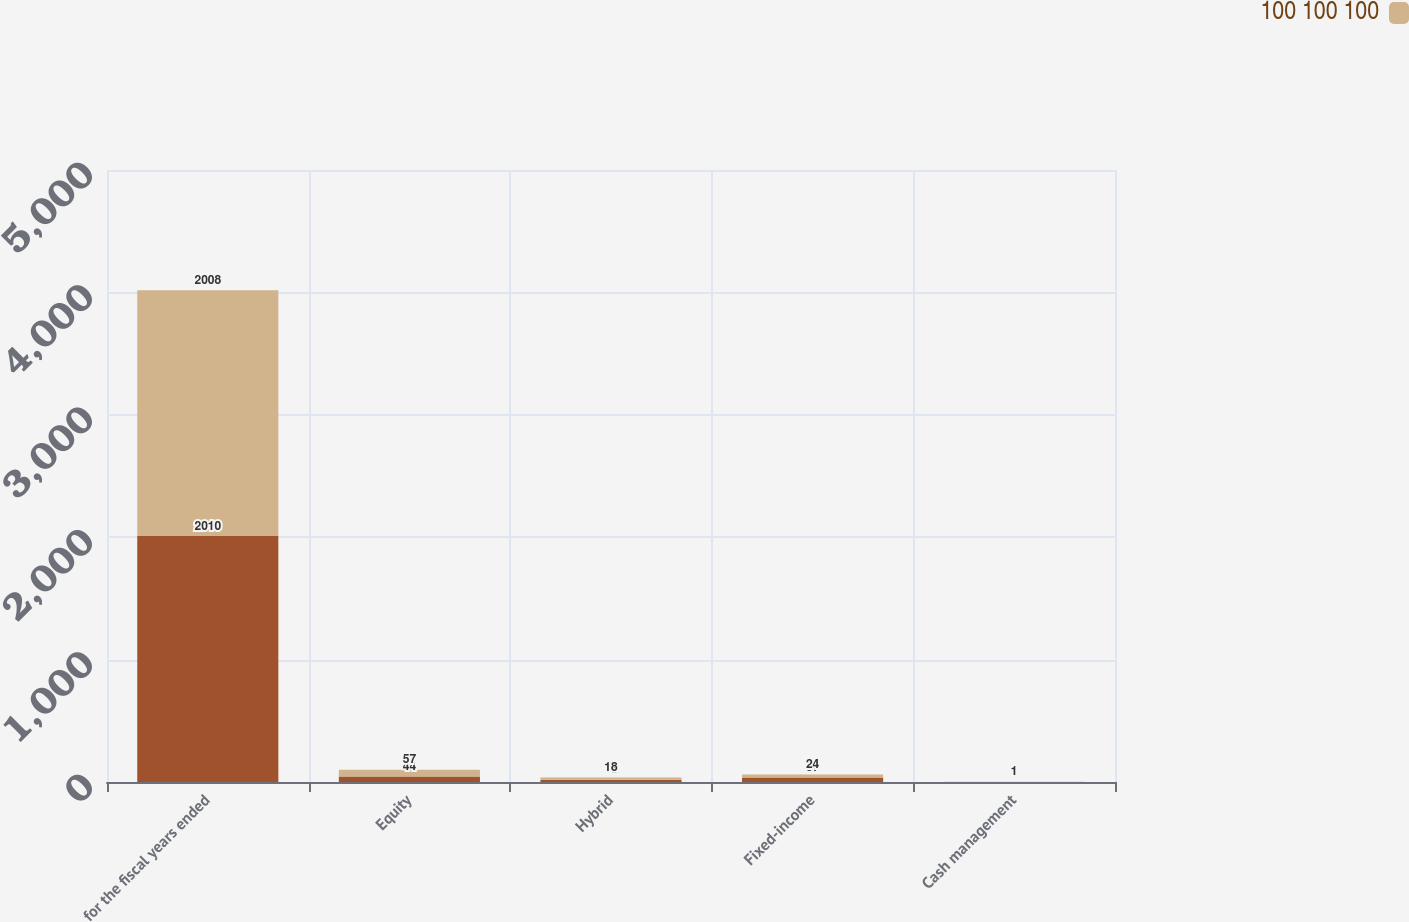Convert chart. <chart><loc_0><loc_0><loc_500><loc_500><stacked_bar_chart><ecel><fcel>for the fiscal years ended<fcel>Equity<fcel>Hybrid<fcel>Fixed-income<fcel>Cash management<nl><fcel>nan<fcel>2010<fcel>44<fcel>18<fcel>37<fcel>1<nl><fcel>100 100 100<fcel>2008<fcel>57<fcel>18<fcel>24<fcel>1<nl></chart> 